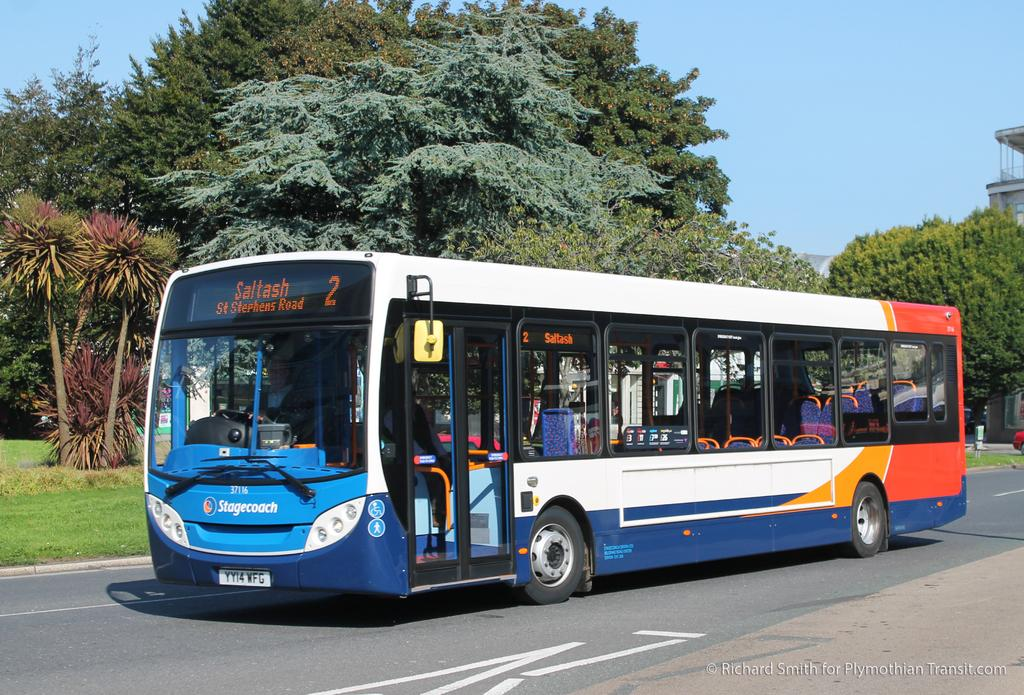Provide a one-sentence caption for the provided image. bus number 2 going to Saltash, St Stephens Road. 